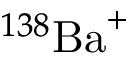<formula> <loc_0><loc_0><loc_500><loc_500>^ { 1 3 8 } { B a } ^ { + }</formula> 